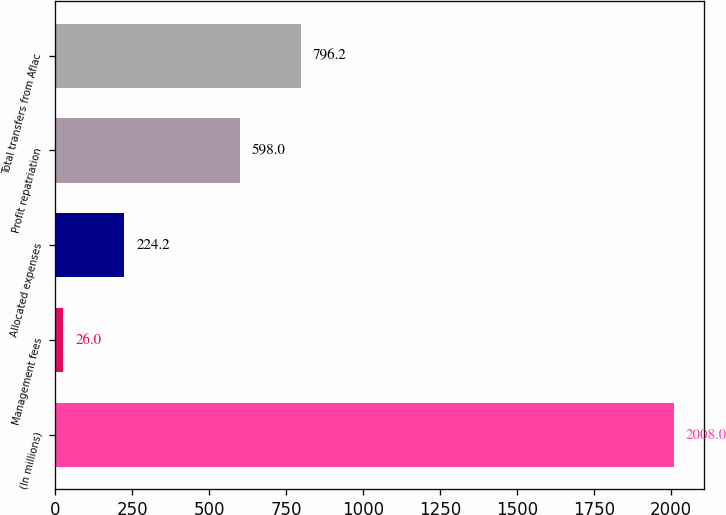Convert chart to OTSL. <chart><loc_0><loc_0><loc_500><loc_500><bar_chart><fcel>(In millions)<fcel>Management fees<fcel>Allocated expenses<fcel>Profit repatriation<fcel>Total transfers from Aflac<nl><fcel>2008<fcel>26<fcel>224.2<fcel>598<fcel>796.2<nl></chart> 